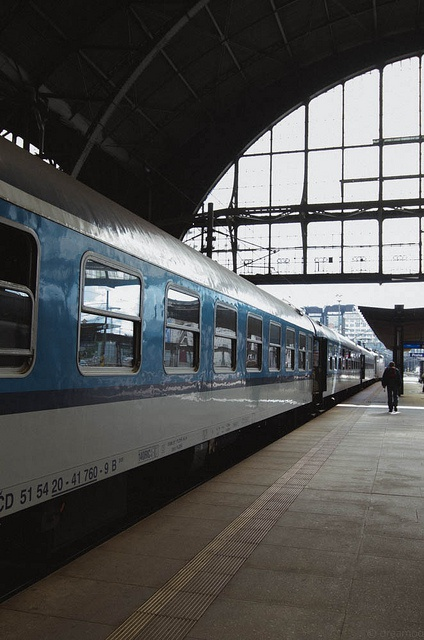Describe the objects in this image and their specific colors. I can see train in black, gray, blue, and lightgray tones and people in black and gray tones in this image. 